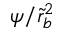<formula> <loc_0><loc_0><loc_500><loc_500>\psi / \tilde { r } _ { b } ^ { 2 }</formula> 